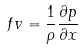Convert formula to latex. <formula><loc_0><loc_0><loc_500><loc_500>f v = \frac { 1 } { \rho } \frac { \partial p } { \partial x }</formula> 